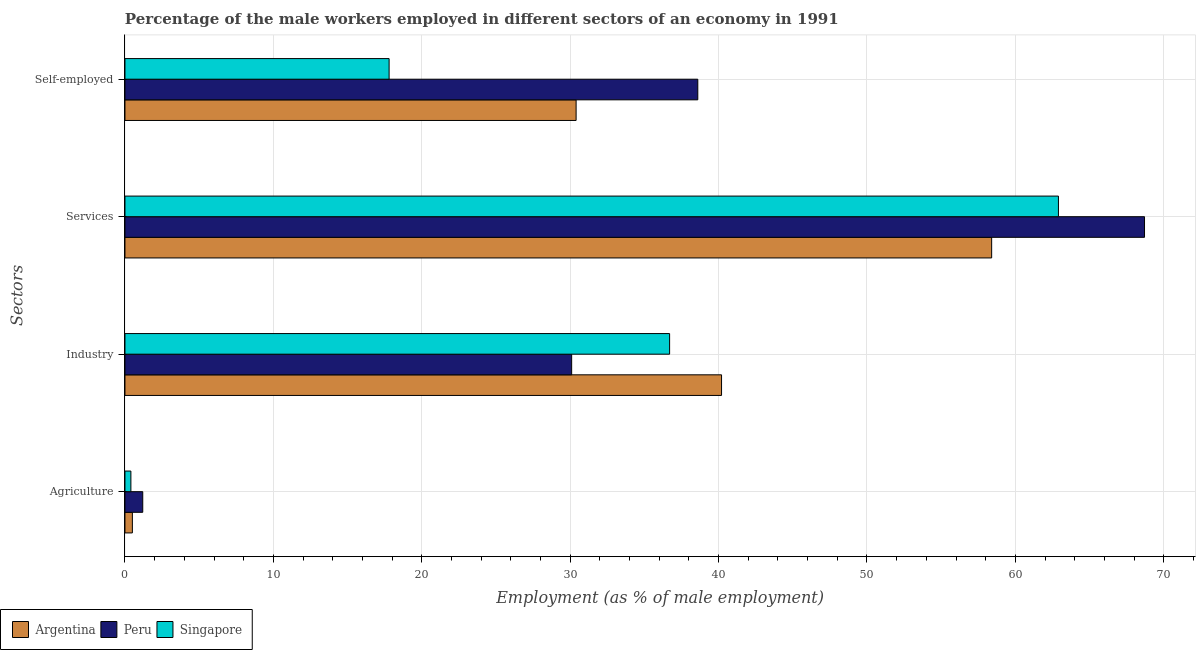What is the label of the 2nd group of bars from the top?
Make the answer very short. Services. What is the percentage of self employed male workers in Singapore?
Offer a terse response. 17.8. Across all countries, what is the maximum percentage of self employed male workers?
Provide a short and direct response. 38.6. Across all countries, what is the minimum percentage of self employed male workers?
Ensure brevity in your answer.  17.8. In which country was the percentage of male workers in agriculture minimum?
Provide a succinct answer. Singapore. What is the total percentage of male workers in agriculture in the graph?
Offer a very short reply. 2.1. What is the difference between the percentage of male workers in industry in Argentina and that in Singapore?
Provide a short and direct response. 3.5. What is the difference between the percentage of male workers in industry in Argentina and the percentage of male workers in agriculture in Peru?
Offer a very short reply. 39. What is the average percentage of male workers in services per country?
Give a very brief answer. 63.33. What is the difference between the percentage of self employed male workers and percentage of male workers in services in Singapore?
Provide a succinct answer. -45.1. In how many countries, is the percentage of male workers in agriculture greater than 32 %?
Keep it short and to the point. 0. What is the ratio of the percentage of male workers in services in Argentina to that in Singapore?
Give a very brief answer. 0.93. What is the difference between the highest and the second highest percentage of self employed male workers?
Provide a succinct answer. 8.2. What is the difference between the highest and the lowest percentage of male workers in agriculture?
Make the answer very short. 0.8. In how many countries, is the percentage of male workers in services greater than the average percentage of male workers in services taken over all countries?
Make the answer very short. 1. Is the sum of the percentage of male workers in industry in Argentina and Peru greater than the maximum percentage of male workers in services across all countries?
Provide a short and direct response. Yes. Is it the case that in every country, the sum of the percentage of male workers in agriculture and percentage of male workers in industry is greater than the sum of percentage of male workers in services and percentage of self employed male workers?
Provide a short and direct response. Yes. What does the 3rd bar from the bottom in Self-employed represents?
Your answer should be compact. Singapore. Is it the case that in every country, the sum of the percentage of male workers in agriculture and percentage of male workers in industry is greater than the percentage of male workers in services?
Ensure brevity in your answer.  No. How many bars are there?
Make the answer very short. 12. How many countries are there in the graph?
Give a very brief answer. 3. Are the values on the major ticks of X-axis written in scientific E-notation?
Keep it short and to the point. No. Does the graph contain any zero values?
Provide a succinct answer. No. Where does the legend appear in the graph?
Your response must be concise. Bottom left. What is the title of the graph?
Your response must be concise. Percentage of the male workers employed in different sectors of an economy in 1991. What is the label or title of the X-axis?
Offer a very short reply. Employment (as % of male employment). What is the label or title of the Y-axis?
Offer a very short reply. Sectors. What is the Employment (as % of male employment) of Peru in Agriculture?
Make the answer very short. 1.2. What is the Employment (as % of male employment) in Singapore in Agriculture?
Your answer should be very brief. 0.4. What is the Employment (as % of male employment) in Argentina in Industry?
Your response must be concise. 40.2. What is the Employment (as % of male employment) in Peru in Industry?
Your answer should be very brief. 30.1. What is the Employment (as % of male employment) in Singapore in Industry?
Your answer should be very brief. 36.7. What is the Employment (as % of male employment) of Argentina in Services?
Provide a short and direct response. 58.4. What is the Employment (as % of male employment) in Peru in Services?
Make the answer very short. 68.7. What is the Employment (as % of male employment) of Singapore in Services?
Provide a succinct answer. 62.9. What is the Employment (as % of male employment) in Argentina in Self-employed?
Give a very brief answer. 30.4. What is the Employment (as % of male employment) of Peru in Self-employed?
Give a very brief answer. 38.6. What is the Employment (as % of male employment) of Singapore in Self-employed?
Provide a short and direct response. 17.8. Across all Sectors, what is the maximum Employment (as % of male employment) of Argentina?
Your answer should be very brief. 58.4. Across all Sectors, what is the maximum Employment (as % of male employment) of Peru?
Your response must be concise. 68.7. Across all Sectors, what is the maximum Employment (as % of male employment) of Singapore?
Make the answer very short. 62.9. Across all Sectors, what is the minimum Employment (as % of male employment) of Peru?
Offer a terse response. 1.2. Across all Sectors, what is the minimum Employment (as % of male employment) in Singapore?
Your answer should be compact. 0.4. What is the total Employment (as % of male employment) in Argentina in the graph?
Make the answer very short. 129.5. What is the total Employment (as % of male employment) in Peru in the graph?
Provide a succinct answer. 138.6. What is the total Employment (as % of male employment) of Singapore in the graph?
Your response must be concise. 117.8. What is the difference between the Employment (as % of male employment) in Argentina in Agriculture and that in Industry?
Provide a succinct answer. -39.7. What is the difference between the Employment (as % of male employment) in Peru in Agriculture and that in Industry?
Offer a terse response. -28.9. What is the difference between the Employment (as % of male employment) of Singapore in Agriculture and that in Industry?
Provide a succinct answer. -36.3. What is the difference between the Employment (as % of male employment) of Argentina in Agriculture and that in Services?
Your response must be concise. -57.9. What is the difference between the Employment (as % of male employment) of Peru in Agriculture and that in Services?
Offer a very short reply. -67.5. What is the difference between the Employment (as % of male employment) of Singapore in Agriculture and that in Services?
Your response must be concise. -62.5. What is the difference between the Employment (as % of male employment) of Argentina in Agriculture and that in Self-employed?
Ensure brevity in your answer.  -29.9. What is the difference between the Employment (as % of male employment) in Peru in Agriculture and that in Self-employed?
Provide a short and direct response. -37.4. What is the difference between the Employment (as % of male employment) in Singapore in Agriculture and that in Self-employed?
Give a very brief answer. -17.4. What is the difference between the Employment (as % of male employment) in Argentina in Industry and that in Services?
Offer a terse response. -18.2. What is the difference between the Employment (as % of male employment) in Peru in Industry and that in Services?
Your response must be concise. -38.6. What is the difference between the Employment (as % of male employment) in Singapore in Industry and that in Services?
Ensure brevity in your answer.  -26.2. What is the difference between the Employment (as % of male employment) in Peru in Industry and that in Self-employed?
Your response must be concise. -8.5. What is the difference between the Employment (as % of male employment) of Peru in Services and that in Self-employed?
Offer a terse response. 30.1. What is the difference between the Employment (as % of male employment) of Singapore in Services and that in Self-employed?
Ensure brevity in your answer.  45.1. What is the difference between the Employment (as % of male employment) in Argentina in Agriculture and the Employment (as % of male employment) in Peru in Industry?
Make the answer very short. -29.6. What is the difference between the Employment (as % of male employment) in Argentina in Agriculture and the Employment (as % of male employment) in Singapore in Industry?
Your answer should be very brief. -36.2. What is the difference between the Employment (as % of male employment) of Peru in Agriculture and the Employment (as % of male employment) of Singapore in Industry?
Your answer should be very brief. -35.5. What is the difference between the Employment (as % of male employment) in Argentina in Agriculture and the Employment (as % of male employment) in Peru in Services?
Offer a very short reply. -68.2. What is the difference between the Employment (as % of male employment) of Argentina in Agriculture and the Employment (as % of male employment) of Singapore in Services?
Offer a terse response. -62.4. What is the difference between the Employment (as % of male employment) of Peru in Agriculture and the Employment (as % of male employment) of Singapore in Services?
Ensure brevity in your answer.  -61.7. What is the difference between the Employment (as % of male employment) of Argentina in Agriculture and the Employment (as % of male employment) of Peru in Self-employed?
Keep it short and to the point. -38.1. What is the difference between the Employment (as % of male employment) of Argentina in Agriculture and the Employment (as % of male employment) of Singapore in Self-employed?
Make the answer very short. -17.3. What is the difference between the Employment (as % of male employment) in Peru in Agriculture and the Employment (as % of male employment) in Singapore in Self-employed?
Make the answer very short. -16.6. What is the difference between the Employment (as % of male employment) in Argentina in Industry and the Employment (as % of male employment) in Peru in Services?
Ensure brevity in your answer.  -28.5. What is the difference between the Employment (as % of male employment) in Argentina in Industry and the Employment (as % of male employment) in Singapore in Services?
Ensure brevity in your answer.  -22.7. What is the difference between the Employment (as % of male employment) of Peru in Industry and the Employment (as % of male employment) of Singapore in Services?
Offer a very short reply. -32.8. What is the difference between the Employment (as % of male employment) of Argentina in Industry and the Employment (as % of male employment) of Singapore in Self-employed?
Ensure brevity in your answer.  22.4. What is the difference between the Employment (as % of male employment) of Argentina in Services and the Employment (as % of male employment) of Peru in Self-employed?
Provide a succinct answer. 19.8. What is the difference between the Employment (as % of male employment) of Argentina in Services and the Employment (as % of male employment) of Singapore in Self-employed?
Provide a succinct answer. 40.6. What is the difference between the Employment (as % of male employment) in Peru in Services and the Employment (as % of male employment) in Singapore in Self-employed?
Provide a short and direct response. 50.9. What is the average Employment (as % of male employment) in Argentina per Sectors?
Provide a short and direct response. 32.38. What is the average Employment (as % of male employment) in Peru per Sectors?
Keep it short and to the point. 34.65. What is the average Employment (as % of male employment) in Singapore per Sectors?
Ensure brevity in your answer.  29.45. What is the difference between the Employment (as % of male employment) of Argentina and Employment (as % of male employment) of Singapore in Agriculture?
Make the answer very short. 0.1. What is the difference between the Employment (as % of male employment) of Argentina and Employment (as % of male employment) of Singapore in Industry?
Give a very brief answer. 3.5. What is the difference between the Employment (as % of male employment) in Peru and Employment (as % of male employment) in Singapore in Industry?
Make the answer very short. -6.6. What is the difference between the Employment (as % of male employment) of Argentina and Employment (as % of male employment) of Peru in Services?
Offer a terse response. -10.3. What is the difference between the Employment (as % of male employment) in Peru and Employment (as % of male employment) in Singapore in Services?
Offer a terse response. 5.8. What is the difference between the Employment (as % of male employment) in Argentina and Employment (as % of male employment) in Singapore in Self-employed?
Make the answer very short. 12.6. What is the difference between the Employment (as % of male employment) in Peru and Employment (as % of male employment) in Singapore in Self-employed?
Your response must be concise. 20.8. What is the ratio of the Employment (as % of male employment) of Argentina in Agriculture to that in Industry?
Make the answer very short. 0.01. What is the ratio of the Employment (as % of male employment) in Peru in Agriculture to that in Industry?
Ensure brevity in your answer.  0.04. What is the ratio of the Employment (as % of male employment) in Singapore in Agriculture to that in Industry?
Ensure brevity in your answer.  0.01. What is the ratio of the Employment (as % of male employment) of Argentina in Agriculture to that in Services?
Provide a succinct answer. 0.01. What is the ratio of the Employment (as % of male employment) in Peru in Agriculture to that in Services?
Provide a short and direct response. 0.02. What is the ratio of the Employment (as % of male employment) in Singapore in Agriculture to that in Services?
Provide a succinct answer. 0.01. What is the ratio of the Employment (as % of male employment) in Argentina in Agriculture to that in Self-employed?
Keep it short and to the point. 0.02. What is the ratio of the Employment (as % of male employment) in Peru in Agriculture to that in Self-employed?
Provide a short and direct response. 0.03. What is the ratio of the Employment (as % of male employment) in Singapore in Agriculture to that in Self-employed?
Provide a succinct answer. 0.02. What is the ratio of the Employment (as % of male employment) of Argentina in Industry to that in Services?
Your answer should be very brief. 0.69. What is the ratio of the Employment (as % of male employment) of Peru in Industry to that in Services?
Provide a succinct answer. 0.44. What is the ratio of the Employment (as % of male employment) in Singapore in Industry to that in Services?
Make the answer very short. 0.58. What is the ratio of the Employment (as % of male employment) of Argentina in Industry to that in Self-employed?
Your response must be concise. 1.32. What is the ratio of the Employment (as % of male employment) in Peru in Industry to that in Self-employed?
Your answer should be compact. 0.78. What is the ratio of the Employment (as % of male employment) in Singapore in Industry to that in Self-employed?
Provide a short and direct response. 2.06. What is the ratio of the Employment (as % of male employment) in Argentina in Services to that in Self-employed?
Your answer should be very brief. 1.92. What is the ratio of the Employment (as % of male employment) of Peru in Services to that in Self-employed?
Your answer should be very brief. 1.78. What is the ratio of the Employment (as % of male employment) of Singapore in Services to that in Self-employed?
Your answer should be compact. 3.53. What is the difference between the highest and the second highest Employment (as % of male employment) in Argentina?
Your response must be concise. 18.2. What is the difference between the highest and the second highest Employment (as % of male employment) in Peru?
Your answer should be very brief. 30.1. What is the difference between the highest and the second highest Employment (as % of male employment) in Singapore?
Offer a terse response. 26.2. What is the difference between the highest and the lowest Employment (as % of male employment) of Argentina?
Provide a succinct answer. 57.9. What is the difference between the highest and the lowest Employment (as % of male employment) in Peru?
Your response must be concise. 67.5. What is the difference between the highest and the lowest Employment (as % of male employment) of Singapore?
Your answer should be very brief. 62.5. 